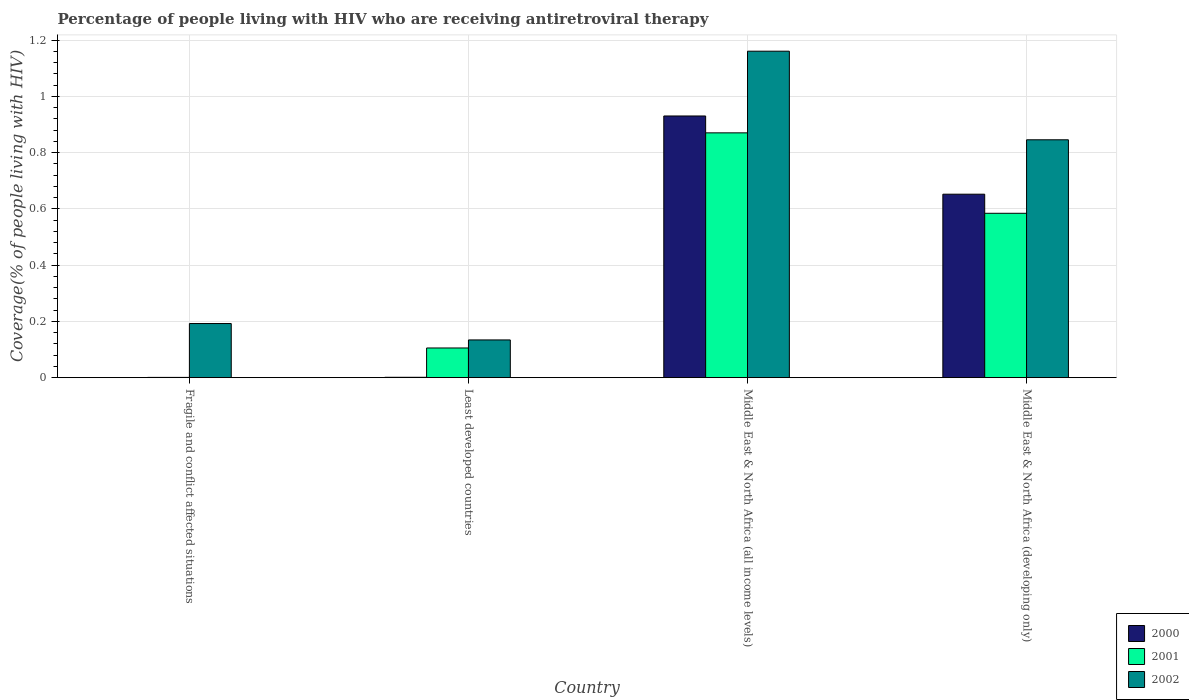How many groups of bars are there?
Your answer should be compact. 4. Are the number of bars per tick equal to the number of legend labels?
Keep it short and to the point. Yes. Are the number of bars on each tick of the X-axis equal?
Your answer should be compact. Yes. What is the label of the 4th group of bars from the left?
Provide a short and direct response. Middle East & North Africa (developing only). In how many cases, is the number of bars for a given country not equal to the number of legend labels?
Make the answer very short. 0. What is the percentage of the HIV infected people who are receiving antiretroviral therapy in 2000 in Middle East & North Africa (all income levels)?
Offer a terse response. 0.93. Across all countries, what is the maximum percentage of the HIV infected people who are receiving antiretroviral therapy in 2000?
Ensure brevity in your answer.  0.93. Across all countries, what is the minimum percentage of the HIV infected people who are receiving antiretroviral therapy in 2002?
Offer a very short reply. 0.13. In which country was the percentage of the HIV infected people who are receiving antiretroviral therapy in 2000 maximum?
Ensure brevity in your answer.  Middle East & North Africa (all income levels). In which country was the percentage of the HIV infected people who are receiving antiretroviral therapy in 2001 minimum?
Keep it short and to the point. Fragile and conflict affected situations. What is the total percentage of the HIV infected people who are receiving antiretroviral therapy in 2002 in the graph?
Ensure brevity in your answer.  2.33. What is the difference between the percentage of the HIV infected people who are receiving antiretroviral therapy in 2000 in Least developed countries and that in Middle East & North Africa (developing only)?
Provide a succinct answer. -0.65. What is the difference between the percentage of the HIV infected people who are receiving antiretroviral therapy in 2001 in Least developed countries and the percentage of the HIV infected people who are receiving antiretroviral therapy in 2000 in Middle East & North Africa (developing only)?
Provide a succinct answer. -0.55. What is the average percentage of the HIV infected people who are receiving antiretroviral therapy in 2000 per country?
Keep it short and to the point. 0.4. What is the difference between the percentage of the HIV infected people who are receiving antiretroviral therapy of/in 2002 and percentage of the HIV infected people who are receiving antiretroviral therapy of/in 2001 in Fragile and conflict affected situations?
Ensure brevity in your answer.  0.19. In how many countries, is the percentage of the HIV infected people who are receiving antiretroviral therapy in 2001 greater than 0.04 %?
Keep it short and to the point. 3. What is the ratio of the percentage of the HIV infected people who are receiving antiretroviral therapy in 2000 in Fragile and conflict affected situations to that in Middle East & North Africa (all income levels)?
Provide a succinct answer. 0. What is the difference between the highest and the second highest percentage of the HIV infected people who are receiving antiretroviral therapy in 2000?
Provide a short and direct response. 0.28. What is the difference between the highest and the lowest percentage of the HIV infected people who are receiving antiretroviral therapy in 2001?
Ensure brevity in your answer.  0.87. What does the 3rd bar from the left in Middle East & North Africa (all income levels) represents?
Keep it short and to the point. 2002. What does the 3rd bar from the right in Middle East & North Africa (developing only) represents?
Ensure brevity in your answer.  2000. Is it the case that in every country, the sum of the percentage of the HIV infected people who are receiving antiretroviral therapy in 2002 and percentage of the HIV infected people who are receiving antiretroviral therapy in 2001 is greater than the percentage of the HIV infected people who are receiving antiretroviral therapy in 2000?
Provide a short and direct response. Yes. How many bars are there?
Make the answer very short. 12. Are all the bars in the graph horizontal?
Keep it short and to the point. No. How many countries are there in the graph?
Provide a succinct answer. 4. What is the difference between two consecutive major ticks on the Y-axis?
Provide a short and direct response. 0.2. How many legend labels are there?
Ensure brevity in your answer.  3. What is the title of the graph?
Your response must be concise. Percentage of people living with HIV who are receiving antiretroviral therapy. What is the label or title of the Y-axis?
Make the answer very short. Coverage(% of people living with HIV). What is the Coverage(% of people living with HIV) of 2000 in Fragile and conflict affected situations?
Keep it short and to the point. 0. What is the Coverage(% of people living with HIV) of 2001 in Fragile and conflict affected situations?
Offer a terse response. 0. What is the Coverage(% of people living with HIV) in 2002 in Fragile and conflict affected situations?
Give a very brief answer. 0.19. What is the Coverage(% of people living with HIV) in 2000 in Least developed countries?
Keep it short and to the point. 0. What is the Coverage(% of people living with HIV) of 2001 in Least developed countries?
Give a very brief answer. 0.11. What is the Coverage(% of people living with HIV) of 2002 in Least developed countries?
Your response must be concise. 0.13. What is the Coverage(% of people living with HIV) in 2000 in Middle East & North Africa (all income levels)?
Your answer should be compact. 0.93. What is the Coverage(% of people living with HIV) in 2001 in Middle East & North Africa (all income levels)?
Your answer should be compact. 0.87. What is the Coverage(% of people living with HIV) of 2002 in Middle East & North Africa (all income levels)?
Your answer should be compact. 1.16. What is the Coverage(% of people living with HIV) of 2000 in Middle East & North Africa (developing only)?
Keep it short and to the point. 0.65. What is the Coverage(% of people living with HIV) in 2001 in Middle East & North Africa (developing only)?
Your answer should be compact. 0.58. What is the Coverage(% of people living with HIV) of 2002 in Middle East & North Africa (developing only)?
Offer a terse response. 0.85. Across all countries, what is the maximum Coverage(% of people living with HIV) in 2000?
Make the answer very short. 0.93. Across all countries, what is the maximum Coverage(% of people living with HIV) in 2001?
Offer a terse response. 0.87. Across all countries, what is the maximum Coverage(% of people living with HIV) of 2002?
Give a very brief answer. 1.16. Across all countries, what is the minimum Coverage(% of people living with HIV) of 2000?
Keep it short and to the point. 0. Across all countries, what is the minimum Coverage(% of people living with HIV) in 2001?
Your response must be concise. 0. Across all countries, what is the minimum Coverage(% of people living with HIV) of 2002?
Your answer should be compact. 0.13. What is the total Coverage(% of people living with HIV) in 2000 in the graph?
Offer a terse response. 1.58. What is the total Coverage(% of people living with HIV) of 2001 in the graph?
Your response must be concise. 1.56. What is the total Coverage(% of people living with HIV) of 2002 in the graph?
Keep it short and to the point. 2.33. What is the difference between the Coverage(% of people living with HIV) of 2000 in Fragile and conflict affected situations and that in Least developed countries?
Provide a succinct answer. -0. What is the difference between the Coverage(% of people living with HIV) in 2001 in Fragile and conflict affected situations and that in Least developed countries?
Your answer should be very brief. -0.1. What is the difference between the Coverage(% of people living with HIV) in 2002 in Fragile and conflict affected situations and that in Least developed countries?
Make the answer very short. 0.06. What is the difference between the Coverage(% of people living with HIV) in 2000 in Fragile and conflict affected situations and that in Middle East & North Africa (all income levels)?
Keep it short and to the point. -0.93. What is the difference between the Coverage(% of people living with HIV) in 2001 in Fragile and conflict affected situations and that in Middle East & North Africa (all income levels)?
Your answer should be very brief. -0.87. What is the difference between the Coverage(% of people living with HIV) in 2002 in Fragile and conflict affected situations and that in Middle East & North Africa (all income levels)?
Make the answer very short. -0.97. What is the difference between the Coverage(% of people living with HIV) in 2000 in Fragile and conflict affected situations and that in Middle East & North Africa (developing only)?
Provide a succinct answer. -0.65. What is the difference between the Coverage(% of people living with HIV) in 2001 in Fragile and conflict affected situations and that in Middle East & North Africa (developing only)?
Provide a short and direct response. -0.58. What is the difference between the Coverage(% of people living with HIV) of 2002 in Fragile and conflict affected situations and that in Middle East & North Africa (developing only)?
Your answer should be very brief. -0.65. What is the difference between the Coverage(% of people living with HIV) of 2000 in Least developed countries and that in Middle East & North Africa (all income levels)?
Provide a succinct answer. -0.93. What is the difference between the Coverage(% of people living with HIV) in 2001 in Least developed countries and that in Middle East & North Africa (all income levels)?
Your answer should be compact. -0.76. What is the difference between the Coverage(% of people living with HIV) in 2002 in Least developed countries and that in Middle East & North Africa (all income levels)?
Provide a short and direct response. -1.03. What is the difference between the Coverage(% of people living with HIV) of 2000 in Least developed countries and that in Middle East & North Africa (developing only)?
Provide a succinct answer. -0.65. What is the difference between the Coverage(% of people living with HIV) of 2001 in Least developed countries and that in Middle East & North Africa (developing only)?
Your answer should be very brief. -0.48. What is the difference between the Coverage(% of people living with HIV) in 2002 in Least developed countries and that in Middle East & North Africa (developing only)?
Make the answer very short. -0.71. What is the difference between the Coverage(% of people living with HIV) in 2000 in Middle East & North Africa (all income levels) and that in Middle East & North Africa (developing only)?
Offer a very short reply. 0.28. What is the difference between the Coverage(% of people living with HIV) of 2001 in Middle East & North Africa (all income levels) and that in Middle East & North Africa (developing only)?
Make the answer very short. 0.29. What is the difference between the Coverage(% of people living with HIV) of 2002 in Middle East & North Africa (all income levels) and that in Middle East & North Africa (developing only)?
Offer a very short reply. 0.31. What is the difference between the Coverage(% of people living with HIV) in 2000 in Fragile and conflict affected situations and the Coverage(% of people living with HIV) in 2001 in Least developed countries?
Ensure brevity in your answer.  -0.1. What is the difference between the Coverage(% of people living with HIV) of 2000 in Fragile and conflict affected situations and the Coverage(% of people living with HIV) of 2002 in Least developed countries?
Provide a succinct answer. -0.13. What is the difference between the Coverage(% of people living with HIV) in 2001 in Fragile and conflict affected situations and the Coverage(% of people living with HIV) in 2002 in Least developed countries?
Provide a short and direct response. -0.13. What is the difference between the Coverage(% of people living with HIV) in 2000 in Fragile and conflict affected situations and the Coverage(% of people living with HIV) in 2001 in Middle East & North Africa (all income levels)?
Provide a short and direct response. -0.87. What is the difference between the Coverage(% of people living with HIV) in 2000 in Fragile and conflict affected situations and the Coverage(% of people living with HIV) in 2002 in Middle East & North Africa (all income levels)?
Make the answer very short. -1.16. What is the difference between the Coverage(% of people living with HIV) in 2001 in Fragile and conflict affected situations and the Coverage(% of people living with HIV) in 2002 in Middle East & North Africa (all income levels)?
Keep it short and to the point. -1.16. What is the difference between the Coverage(% of people living with HIV) in 2000 in Fragile and conflict affected situations and the Coverage(% of people living with HIV) in 2001 in Middle East & North Africa (developing only)?
Your answer should be compact. -0.58. What is the difference between the Coverage(% of people living with HIV) in 2000 in Fragile and conflict affected situations and the Coverage(% of people living with HIV) in 2002 in Middle East & North Africa (developing only)?
Offer a terse response. -0.85. What is the difference between the Coverage(% of people living with HIV) of 2001 in Fragile and conflict affected situations and the Coverage(% of people living with HIV) of 2002 in Middle East & North Africa (developing only)?
Provide a short and direct response. -0.84. What is the difference between the Coverage(% of people living with HIV) of 2000 in Least developed countries and the Coverage(% of people living with HIV) of 2001 in Middle East & North Africa (all income levels)?
Offer a terse response. -0.87. What is the difference between the Coverage(% of people living with HIV) in 2000 in Least developed countries and the Coverage(% of people living with HIV) in 2002 in Middle East & North Africa (all income levels)?
Your answer should be compact. -1.16. What is the difference between the Coverage(% of people living with HIV) in 2001 in Least developed countries and the Coverage(% of people living with HIV) in 2002 in Middle East & North Africa (all income levels)?
Your answer should be very brief. -1.05. What is the difference between the Coverage(% of people living with HIV) in 2000 in Least developed countries and the Coverage(% of people living with HIV) in 2001 in Middle East & North Africa (developing only)?
Your answer should be compact. -0.58. What is the difference between the Coverage(% of people living with HIV) of 2000 in Least developed countries and the Coverage(% of people living with HIV) of 2002 in Middle East & North Africa (developing only)?
Offer a terse response. -0.84. What is the difference between the Coverage(% of people living with HIV) in 2001 in Least developed countries and the Coverage(% of people living with HIV) in 2002 in Middle East & North Africa (developing only)?
Offer a very short reply. -0.74. What is the difference between the Coverage(% of people living with HIV) of 2000 in Middle East & North Africa (all income levels) and the Coverage(% of people living with HIV) of 2001 in Middle East & North Africa (developing only)?
Your answer should be compact. 0.35. What is the difference between the Coverage(% of people living with HIV) of 2000 in Middle East & North Africa (all income levels) and the Coverage(% of people living with HIV) of 2002 in Middle East & North Africa (developing only)?
Offer a terse response. 0.08. What is the difference between the Coverage(% of people living with HIV) in 2001 in Middle East & North Africa (all income levels) and the Coverage(% of people living with HIV) in 2002 in Middle East & North Africa (developing only)?
Give a very brief answer. 0.02. What is the average Coverage(% of people living with HIV) in 2000 per country?
Keep it short and to the point. 0.4. What is the average Coverage(% of people living with HIV) in 2001 per country?
Keep it short and to the point. 0.39. What is the average Coverage(% of people living with HIV) in 2002 per country?
Your answer should be compact. 0.58. What is the difference between the Coverage(% of people living with HIV) in 2000 and Coverage(% of people living with HIV) in 2001 in Fragile and conflict affected situations?
Your answer should be compact. -0. What is the difference between the Coverage(% of people living with HIV) of 2000 and Coverage(% of people living with HIV) of 2002 in Fragile and conflict affected situations?
Your answer should be very brief. -0.19. What is the difference between the Coverage(% of people living with HIV) in 2001 and Coverage(% of people living with HIV) in 2002 in Fragile and conflict affected situations?
Keep it short and to the point. -0.19. What is the difference between the Coverage(% of people living with HIV) of 2000 and Coverage(% of people living with HIV) of 2001 in Least developed countries?
Provide a succinct answer. -0.1. What is the difference between the Coverage(% of people living with HIV) in 2000 and Coverage(% of people living with HIV) in 2002 in Least developed countries?
Your answer should be very brief. -0.13. What is the difference between the Coverage(% of people living with HIV) of 2001 and Coverage(% of people living with HIV) of 2002 in Least developed countries?
Ensure brevity in your answer.  -0.03. What is the difference between the Coverage(% of people living with HIV) in 2000 and Coverage(% of people living with HIV) in 2002 in Middle East & North Africa (all income levels)?
Provide a succinct answer. -0.23. What is the difference between the Coverage(% of people living with HIV) of 2001 and Coverage(% of people living with HIV) of 2002 in Middle East & North Africa (all income levels)?
Offer a very short reply. -0.29. What is the difference between the Coverage(% of people living with HIV) in 2000 and Coverage(% of people living with HIV) in 2001 in Middle East & North Africa (developing only)?
Ensure brevity in your answer.  0.07. What is the difference between the Coverage(% of people living with HIV) in 2000 and Coverage(% of people living with HIV) in 2002 in Middle East & North Africa (developing only)?
Provide a short and direct response. -0.19. What is the difference between the Coverage(% of people living with HIV) in 2001 and Coverage(% of people living with HIV) in 2002 in Middle East & North Africa (developing only)?
Provide a succinct answer. -0.26. What is the ratio of the Coverage(% of people living with HIV) of 2000 in Fragile and conflict affected situations to that in Least developed countries?
Ensure brevity in your answer.  0.36. What is the ratio of the Coverage(% of people living with HIV) in 2001 in Fragile and conflict affected situations to that in Least developed countries?
Provide a succinct answer. 0.01. What is the ratio of the Coverage(% of people living with HIV) in 2002 in Fragile and conflict affected situations to that in Least developed countries?
Offer a terse response. 1.43. What is the ratio of the Coverage(% of people living with HIV) in 2000 in Fragile and conflict affected situations to that in Middle East & North Africa (all income levels)?
Your answer should be compact. 0. What is the ratio of the Coverage(% of people living with HIV) of 2001 in Fragile and conflict affected situations to that in Middle East & North Africa (all income levels)?
Your answer should be very brief. 0. What is the ratio of the Coverage(% of people living with HIV) of 2002 in Fragile and conflict affected situations to that in Middle East & North Africa (all income levels)?
Your response must be concise. 0.17. What is the ratio of the Coverage(% of people living with HIV) of 2000 in Fragile and conflict affected situations to that in Middle East & North Africa (developing only)?
Give a very brief answer. 0. What is the ratio of the Coverage(% of people living with HIV) of 2001 in Fragile and conflict affected situations to that in Middle East & North Africa (developing only)?
Offer a terse response. 0. What is the ratio of the Coverage(% of people living with HIV) in 2002 in Fragile and conflict affected situations to that in Middle East & North Africa (developing only)?
Offer a very short reply. 0.23. What is the ratio of the Coverage(% of people living with HIV) in 2000 in Least developed countries to that in Middle East & North Africa (all income levels)?
Provide a short and direct response. 0. What is the ratio of the Coverage(% of people living with HIV) in 2001 in Least developed countries to that in Middle East & North Africa (all income levels)?
Provide a short and direct response. 0.12. What is the ratio of the Coverage(% of people living with HIV) in 2002 in Least developed countries to that in Middle East & North Africa (all income levels)?
Offer a very short reply. 0.12. What is the ratio of the Coverage(% of people living with HIV) of 2000 in Least developed countries to that in Middle East & North Africa (developing only)?
Provide a succinct answer. 0. What is the ratio of the Coverage(% of people living with HIV) of 2001 in Least developed countries to that in Middle East & North Africa (developing only)?
Your response must be concise. 0.18. What is the ratio of the Coverage(% of people living with HIV) in 2002 in Least developed countries to that in Middle East & North Africa (developing only)?
Your answer should be compact. 0.16. What is the ratio of the Coverage(% of people living with HIV) in 2000 in Middle East & North Africa (all income levels) to that in Middle East & North Africa (developing only)?
Your answer should be very brief. 1.43. What is the ratio of the Coverage(% of people living with HIV) of 2001 in Middle East & North Africa (all income levels) to that in Middle East & North Africa (developing only)?
Ensure brevity in your answer.  1.49. What is the ratio of the Coverage(% of people living with HIV) of 2002 in Middle East & North Africa (all income levels) to that in Middle East & North Africa (developing only)?
Give a very brief answer. 1.37. What is the difference between the highest and the second highest Coverage(% of people living with HIV) in 2000?
Provide a short and direct response. 0.28. What is the difference between the highest and the second highest Coverage(% of people living with HIV) in 2001?
Provide a succinct answer. 0.29. What is the difference between the highest and the second highest Coverage(% of people living with HIV) of 2002?
Your answer should be compact. 0.31. What is the difference between the highest and the lowest Coverage(% of people living with HIV) in 2000?
Ensure brevity in your answer.  0.93. What is the difference between the highest and the lowest Coverage(% of people living with HIV) of 2001?
Make the answer very short. 0.87. What is the difference between the highest and the lowest Coverage(% of people living with HIV) of 2002?
Ensure brevity in your answer.  1.03. 